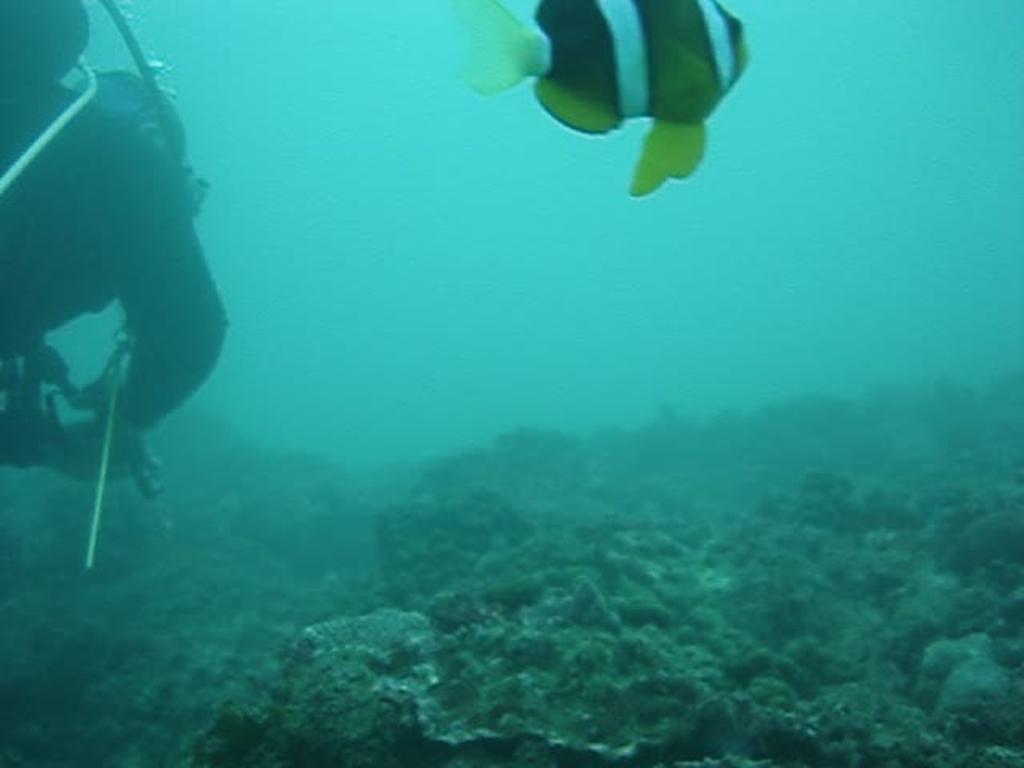How would you summarize this image in a sentence or two? In this image I can see a fish, submarine plants, person and a oxygen cylinder in the water. This image is taken may be in the sea. 